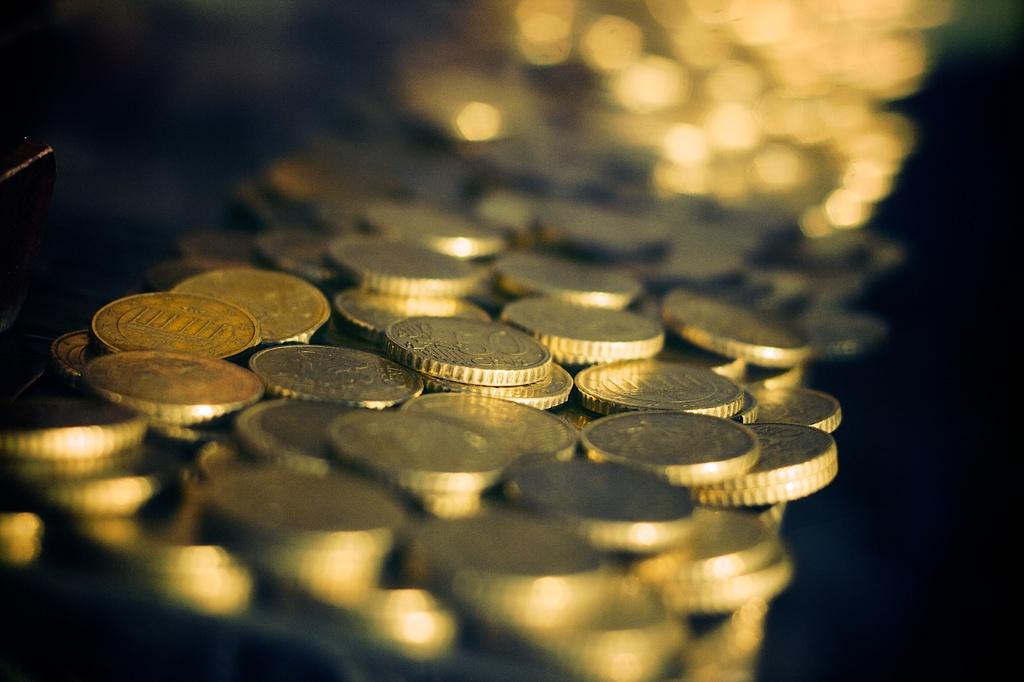What objects are in the foreground of the image? There are currency coins in the foreground of the image. How would you describe the background of the image? The background of the image is blurry. Can you identify any specific features in the background? Yes, there are lights visible in the background of the image. What trick is the stranger performing with the territory in the image? There is no trick, stranger, or territory present in the image. 